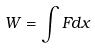<formula> <loc_0><loc_0><loc_500><loc_500>W = \int F d x</formula> 